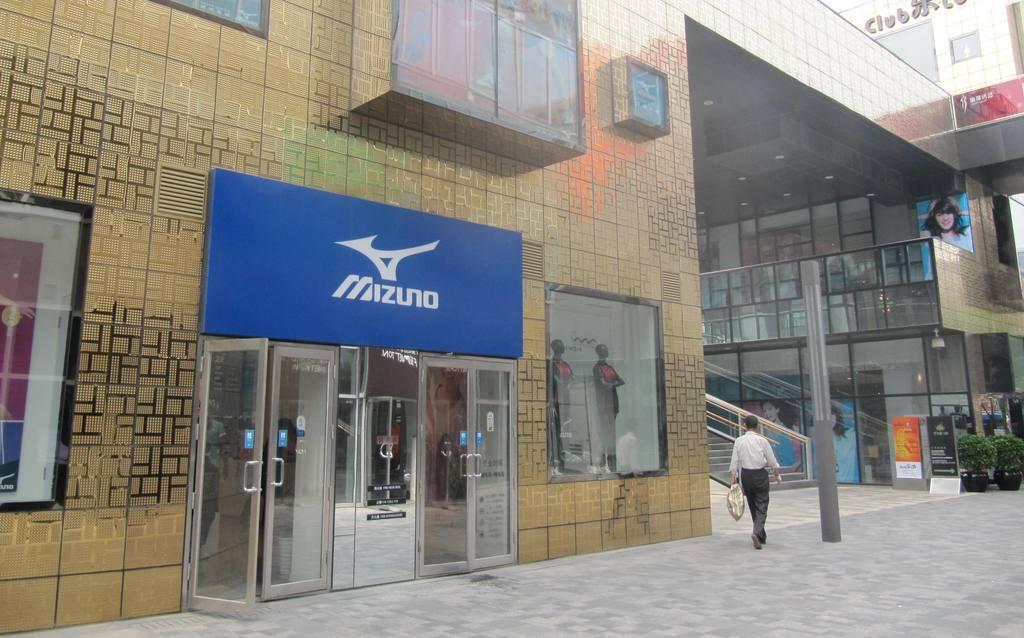In one or two sentences, can you explain what this image depicts? In this image I can see the building, glass doors, boards, mannequins, stairs, glass fencing, pole and one person is walking and holding something. 